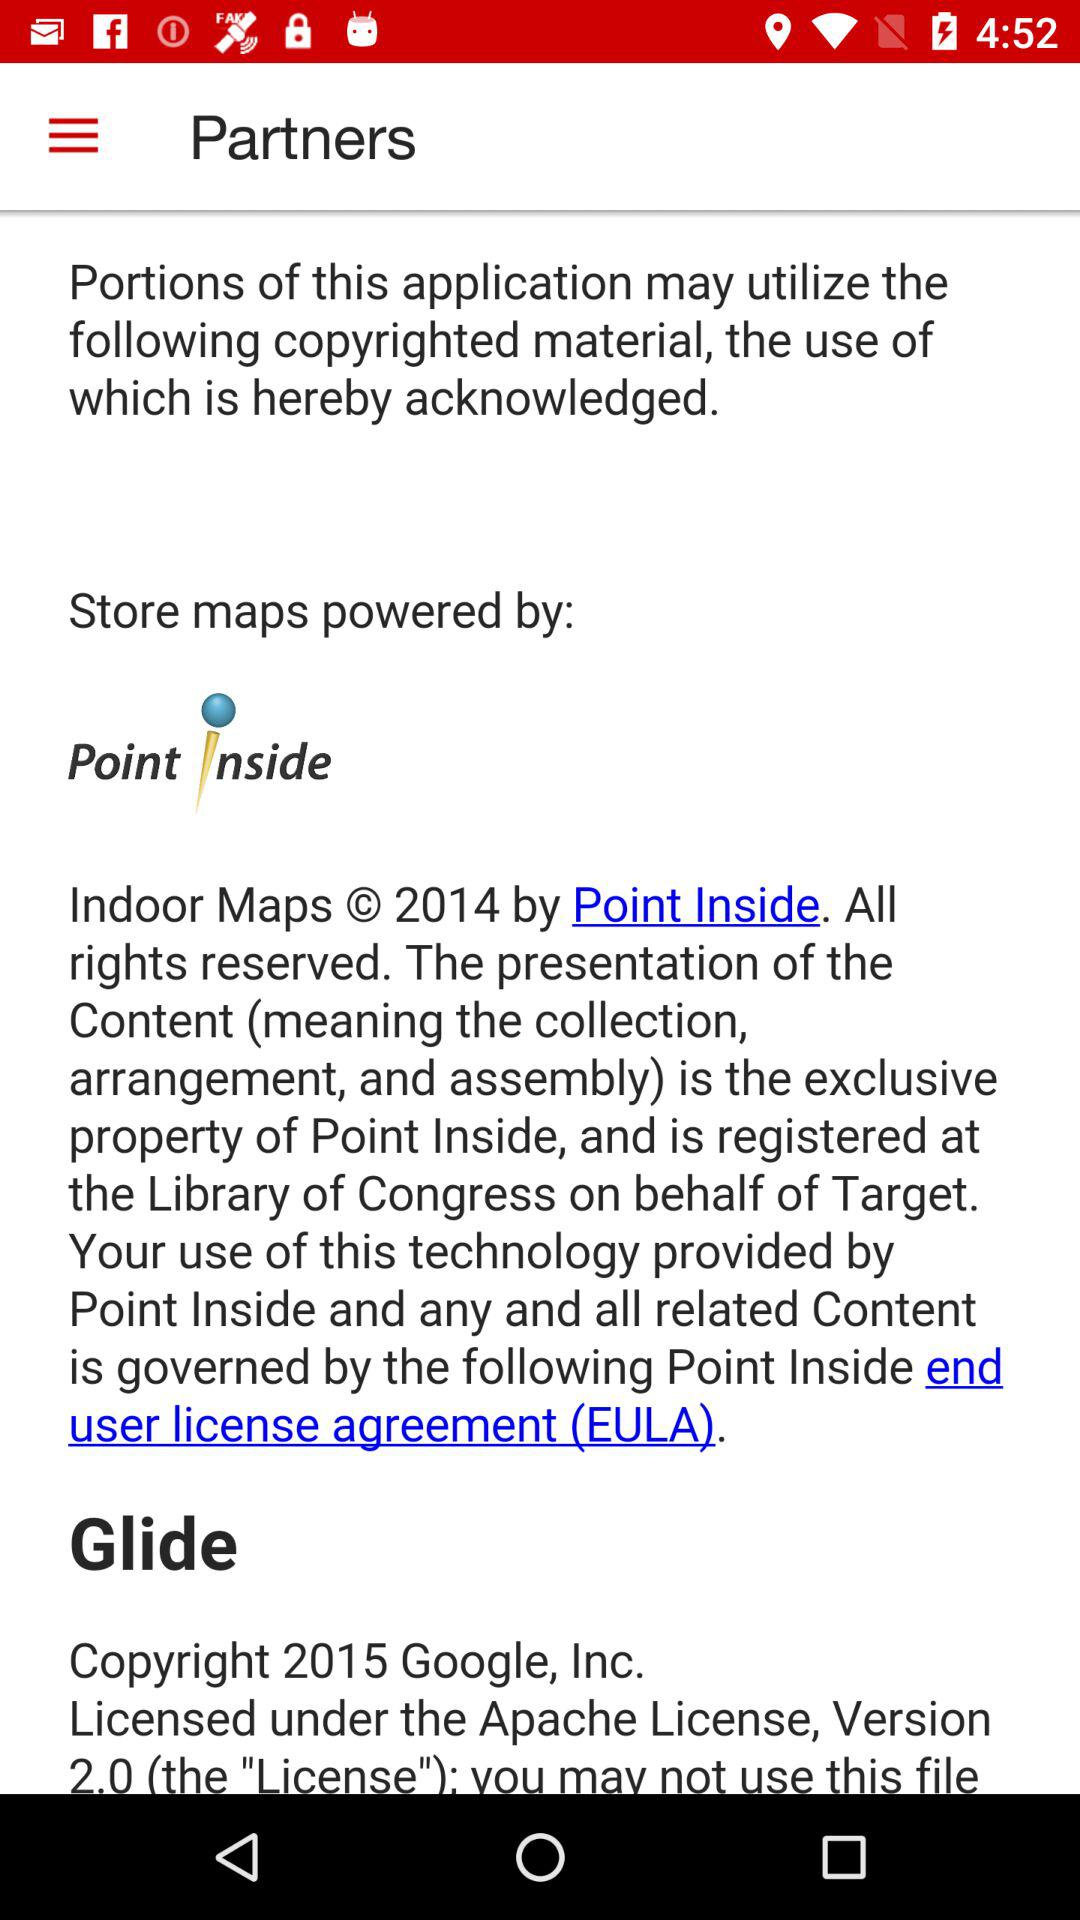How many copyright notices are there?
Answer the question using a single word or phrase. 2 